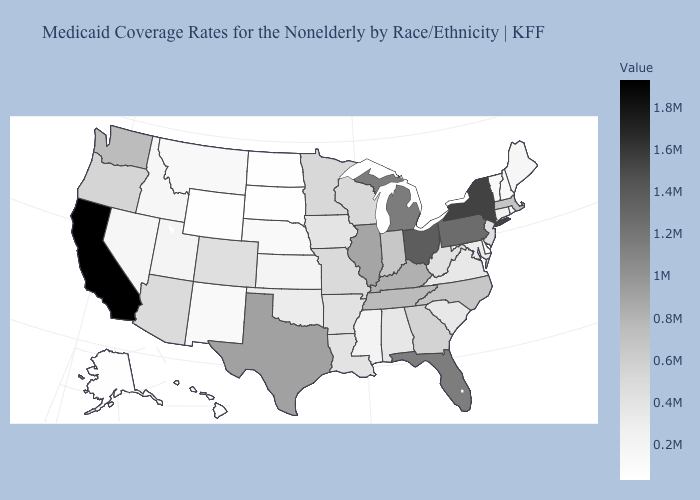Does the map have missing data?
Concise answer only. No. Which states have the highest value in the USA?
Concise answer only. California. Does the map have missing data?
Keep it brief. No. Which states have the highest value in the USA?
Keep it brief. California. Does Utah have the highest value in the USA?
Concise answer only. No. Does Virginia have the lowest value in the South?
Keep it brief. No. 